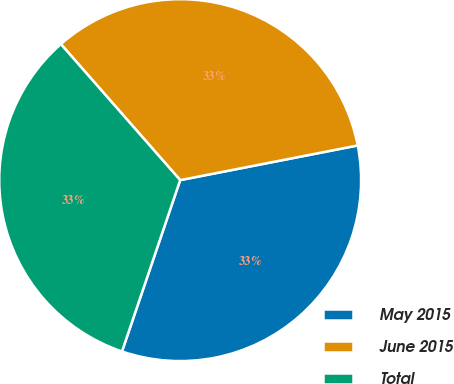Convert chart to OTSL. <chart><loc_0><loc_0><loc_500><loc_500><pie_chart><fcel>May 2015<fcel>June 2015<fcel>Total<nl><fcel>33.28%<fcel>33.39%<fcel>33.33%<nl></chart> 